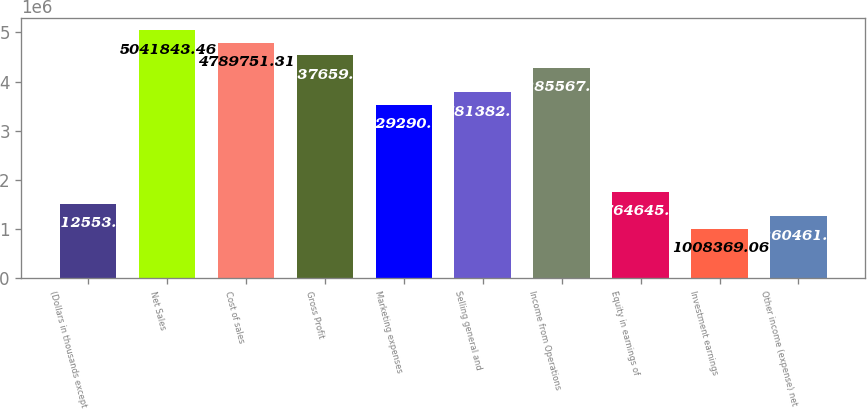Convert chart to OTSL. <chart><loc_0><loc_0><loc_500><loc_500><bar_chart><fcel>(Dollars in thousands except<fcel>Net Sales<fcel>Cost of sales<fcel>Gross Profit<fcel>Marketing expenses<fcel>Selling general and<fcel>Income from Operations<fcel>Equity in earnings of<fcel>Investment earnings<fcel>Other income (expense) net<nl><fcel>1.51255e+06<fcel>5.04184e+06<fcel>4.78975e+06<fcel>4.53766e+06<fcel>3.52929e+06<fcel>3.78138e+06<fcel>4.28557e+06<fcel>1.76465e+06<fcel>1.00837e+06<fcel>1.26046e+06<nl></chart> 